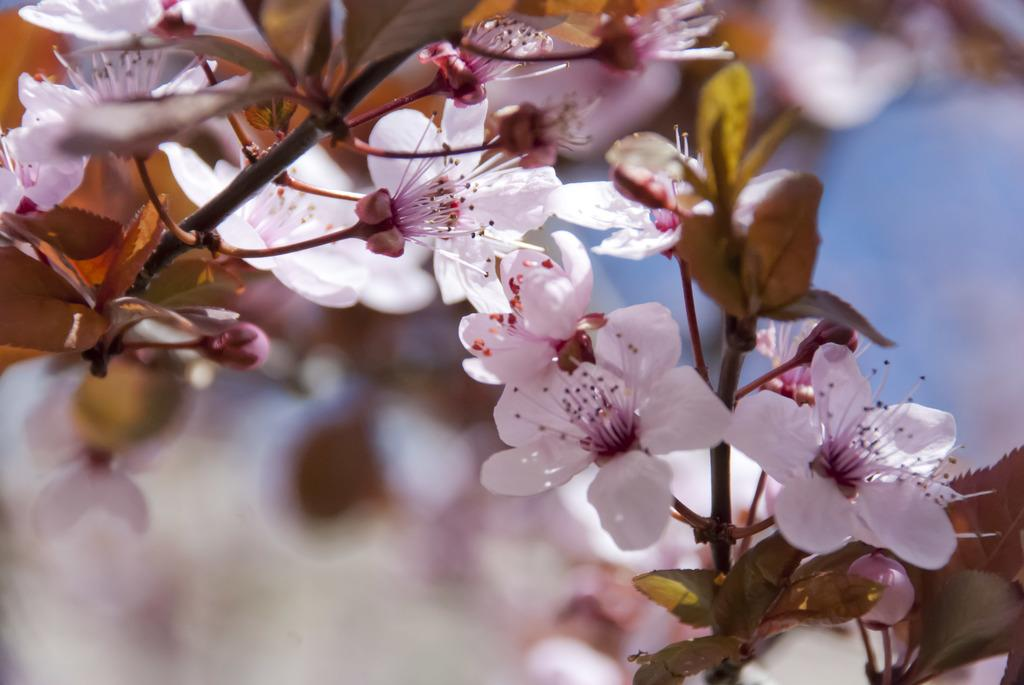What type of vegetation can be seen on the branches of the tree in the image? There are flowers on the branches of the tree in the image. What is the price of the rock that is being hated in the image? There is no rock or mention of hate in the image; it only features a tree with flowers on its branches. 